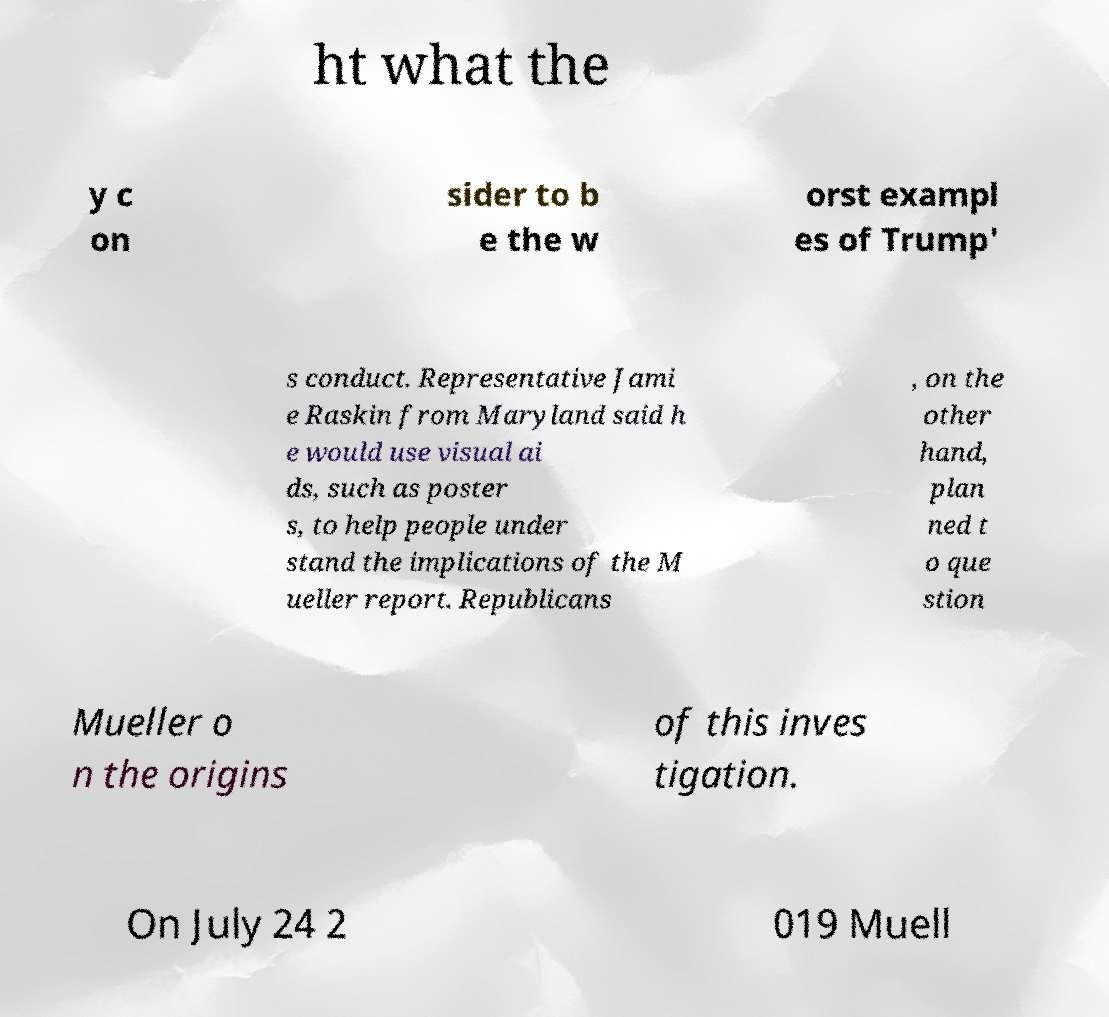Could you extract and type out the text from this image? ht what the y c on sider to b e the w orst exampl es of Trump' s conduct. Representative Jami e Raskin from Maryland said h e would use visual ai ds, such as poster s, to help people under stand the implications of the M ueller report. Republicans , on the other hand, plan ned t o que stion Mueller o n the origins of this inves tigation. On July 24 2 019 Muell 